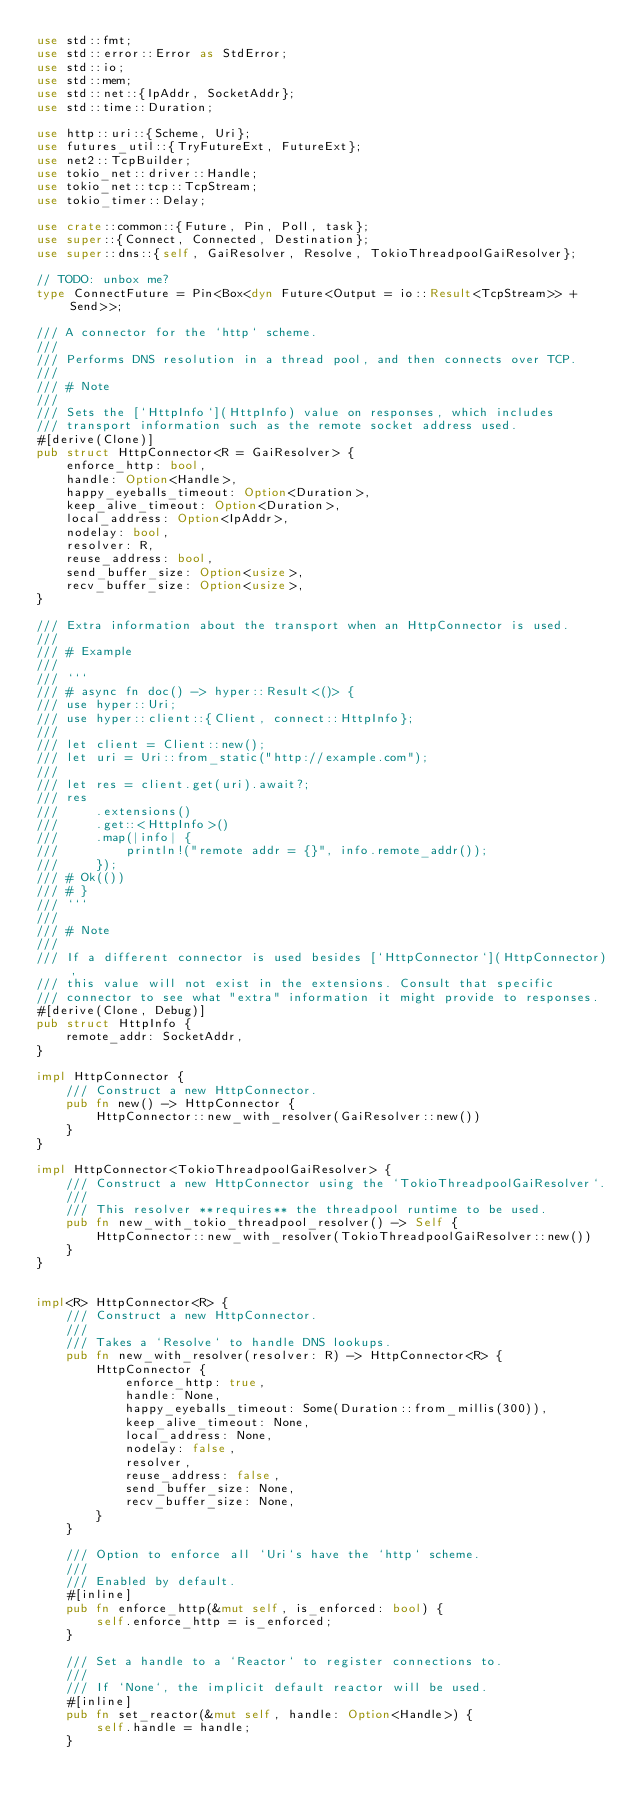Convert code to text. <code><loc_0><loc_0><loc_500><loc_500><_Rust_>use std::fmt;
use std::error::Error as StdError;
use std::io;
use std::mem;
use std::net::{IpAddr, SocketAddr};
use std::time::Duration;

use http::uri::{Scheme, Uri};
use futures_util::{TryFutureExt, FutureExt};
use net2::TcpBuilder;
use tokio_net::driver::Handle;
use tokio_net::tcp::TcpStream;
use tokio_timer::Delay;

use crate::common::{Future, Pin, Poll, task};
use super::{Connect, Connected, Destination};
use super::dns::{self, GaiResolver, Resolve, TokioThreadpoolGaiResolver};

// TODO: unbox me?
type ConnectFuture = Pin<Box<dyn Future<Output = io::Result<TcpStream>> + Send>>;

/// A connector for the `http` scheme.
///
/// Performs DNS resolution in a thread pool, and then connects over TCP.
///
/// # Note
///
/// Sets the [`HttpInfo`](HttpInfo) value on responses, which includes
/// transport information such as the remote socket address used.
#[derive(Clone)]
pub struct HttpConnector<R = GaiResolver> {
    enforce_http: bool,
    handle: Option<Handle>,
    happy_eyeballs_timeout: Option<Duration>,
    keep_alive_timeout: Option<Duration>,
    local_address: Option<IpAddr>,
    nodelay: bool,
    resolver: R,
    reuse_address: bool,
    send_buffer_size: Option<usize>,
    recv_buffer_size: Option<usize>,
}

/// Extra information about the transport when an HttpConnector is used.
///
/// # Example
///
/// ```
/// # async fn doc() -> hyper::Result<()> {
/// use hyper::Uri;
/// use hyper::client::{Client, connect::HttpInfo};
///
/// let client = Client::new();
/// let uri = Uri::from_static("http://example.com");
///
/// let res = client.get(uri).await?;
/// res
///     .extensions()
///     .get::<HttpInfo>()
///     .map(|info| {
///         println!("remote addr = {}", info.remote_addr());
///     });
/// # Ok(())
/// # }
/// ```
///
/// # Note
///
/// If a different connector is used besides [`HttpConnector`](HttpConnector),
/// this value will not exist in the extensions. Consult that specific
/// connector to see what "extra" information it might provide to responses.
#[derive(Clone, Debug)]
pub struct HttpInfo {
    remote_addr: SocketAddr,
}

impl HttpConnector {
    /// Construct a new HttpConnector.
    pub fn new() -> HttpConnector {
        HttpConnector::new_with_resolver(GaiResolver::new())
    }
}

impl HttpConnector<TokioThreadpoolGaiResolver> {
    /// Construct a new HttpConnector using the `TokioThreadpoolGaiResolver`.
    ///
    /// This resolver **requires** the threadpool runtime to be used.
    pub fn new_with_tokio_threadpool_resolver() -> Self {
        HttpConnector::new_with_resolver(TokioThreadpoolGaiResolver::new())
    }
}


impl<R> HttpConnector<R> {
    /// Construct a new HttpConnector.
    ///
    /// Takes a `Resolve` to handle DNS lookups.
    pub fn new_with_resolver(resolver: R) -> HttpConnector<R> {
        HttpConnector {
            enforce_http: true,
            handle: None,
            happy_eyeballs_timeout: Some(Duration::from_millis(300)),
            keep_alive_timeout: None,
            local_address: None,
            nodelay: false,
            resolver,
            reuse_address: false,
            send_buffer_size: None,
            recv_buffer_size: None,
        }
    }

    /// Option to enforce all `Uri`s have the `http` scheme.
    ///
    /// Enabled by default.
    #[inline]
    pub fn enforce_http(&mut self, is_enforced: bool) {
        self.enforce_http = is_enforced;
    }

    /// Set a handle to a `Reactor` to register connections to.
    ///
    /// If `None`, the implicit default reactor will be used.
    #[inline]
    pub fn set_reactor(&mut self, handle: Option<Handle>) {
        self.handle = handle;
    }
</code> 